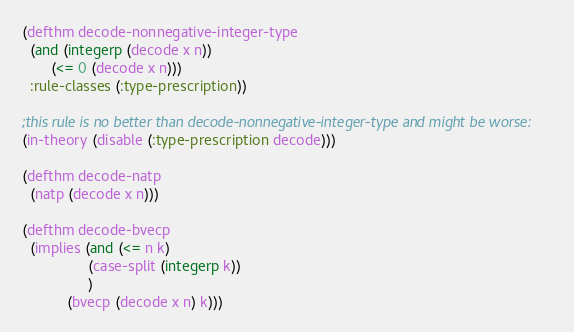<code> <loc_0><loc_0><loc_500><loc_500><_Lisp_>
(defthm decode-nonnegative-integer-type
  (and (integerp (decode x n))
       (<= 0 (decode x n)))
  :rule-classes (:type-prescription))

;this rule is no better than decode-nonnegative-integer-type and might be worse:
(in-theory (disable (:type-prescription decode)))

(defthm decode-natp
  (natp (decode x n)))

(defthm decode-bvecp
  (implies (and (<= n k)
                (case-split (integerp k))
                )
           (bvecp (decode x n) k)))

</code> 